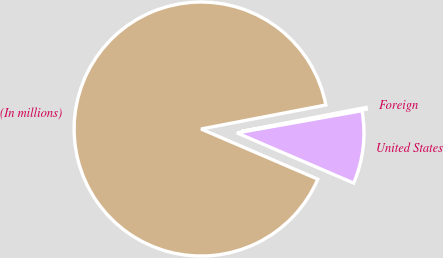<chart> <loc_0><loc_0><loc_500><loc_500><pie_chart><fcel>(In millions)<fcel>United States<fcel>Foreign<nl><fcel>90.52%<fcel>9.26%<fcel>0.23%<nl></chart> 